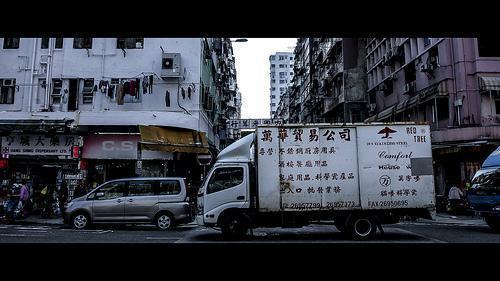How many vehicles are there?
Give a very brief answer. 3. How many doors are on the side of the first vehicle?
Give a very brief answer. 2. 